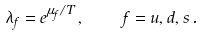<formula> <loc_0><loc_0><loc_500><loc_500>\lambda _ { f } = e ^ { \mu _ { f } / T } \, , \quad f = u , d , s \, .</formula> 